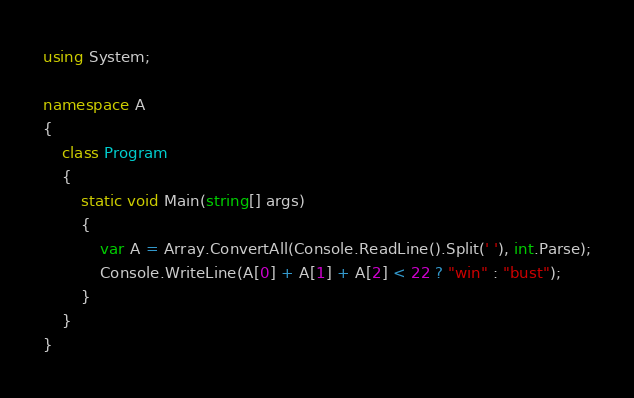<code> <loc_0><loc_0><loc_500><loc_500><_C#_>using System;

namespace A
{
    class Program
    {
        static void Main(string[] args)
        {
            var A = Array.ConvertAll(Console.ReadLine().Split(' '), int.Parse);
            Console.WriteLine(A[0] + A[1] + A[2] < 22 ? "win" : "bust");
        }
    }
}
</code> 